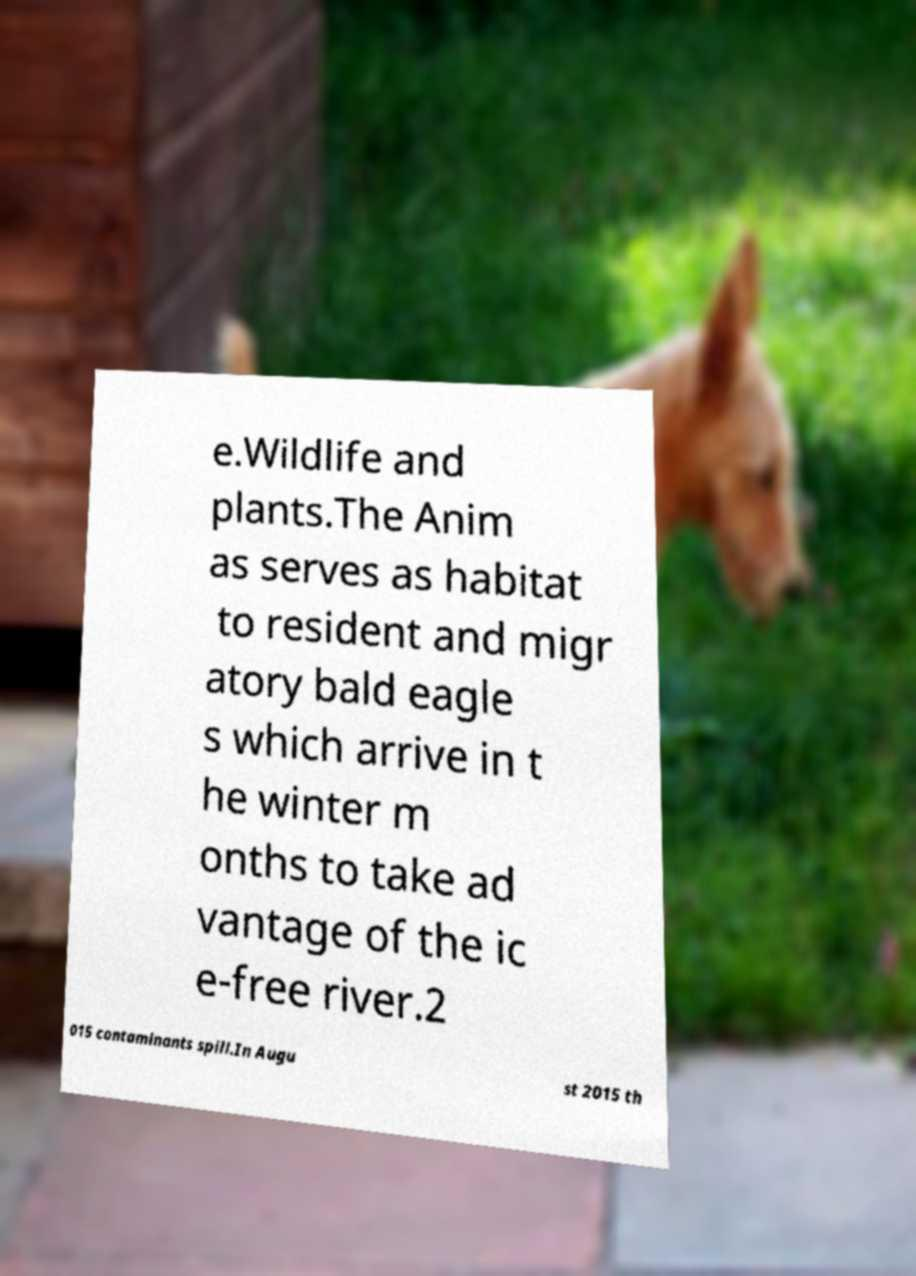Could you assist in decoding the text presented in this image and type it out clearly? e.Wildlife and plants.The Anim as serves as habitat to resident and migr atory bald eagle s which arrive in t he winter m onths to take ad vantage of the ic e-free river.2 015 contaminants spill.In Augu st 2015 th 